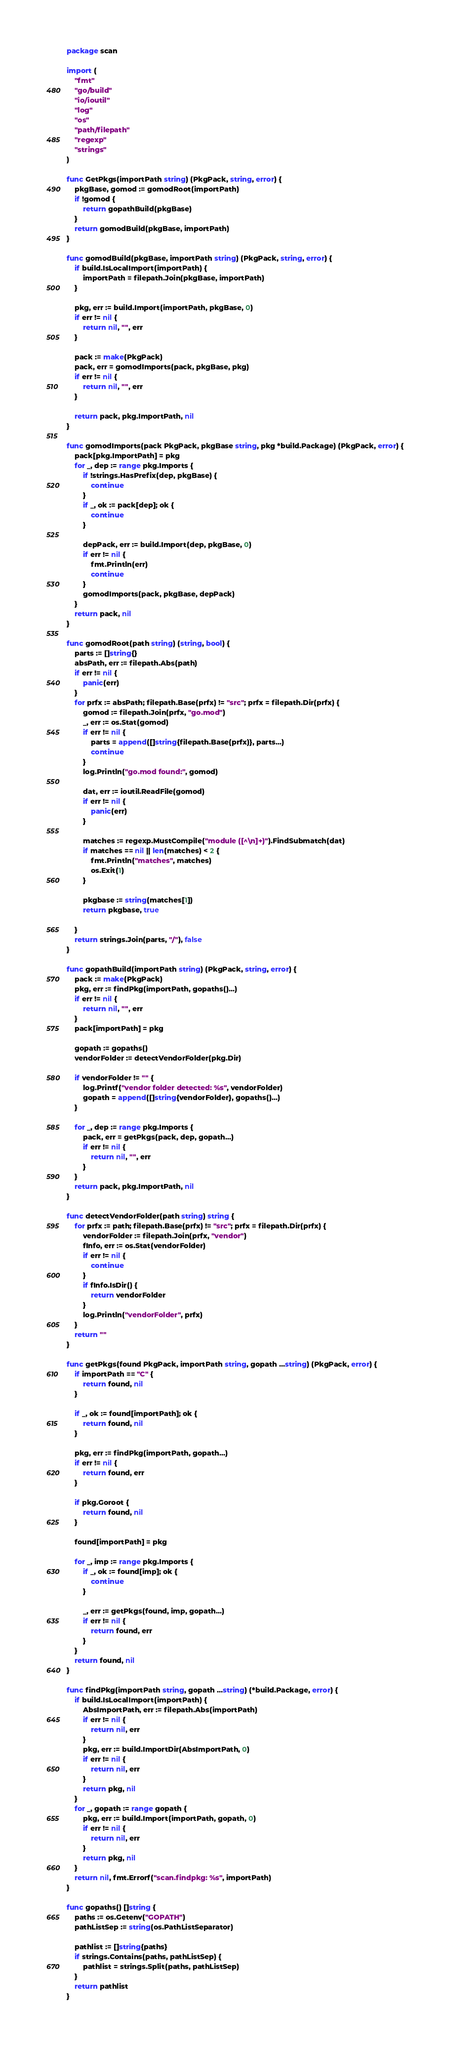Convert code to text. <code><loc_0><loc_0><loc_500><loc_500><_Go_>package scan

import (
	"fmt"
	"go/build"
	"io/ioutil"
	"log"
	"os"
	"path/filepath"
	"regexp"
	"strings"
)

func GetPkgs(importPath string) (PkgPack, string, error) {
	pkgBase, gomod := gomodRoot(importPath)
	if !gomod {
		return gopathBuild(pkgBase)
	}
	return gomodBuild(pkgBase, importPath)
}

func gomodBuild(pkgBase, importPath string) (PkgPack, string, error) {
	if build.IsLocalImport(importPath) {
		importPath = filepath.Join(pkgBase, importPath)
	}

	pkg, err := build.Import(importPath, pkgBase, 0)
	if err != nil {
		return nil, "", err
	}

	pack := make(PkgPack)
	pack, err = gomodImports(pack, pkgBase, pkg)
	if err != nil {
		return nil, "", err
	}

	return pack, pkg.ImportPath, nil
}

func gomodImports(pack PkgPack, pkgBase string, pkg *build.Package) (PkgPack, error) {
	pack[pkg.ImportPath] = pkg
	for _, dep := range pkg.Imports {
		if !strings.HasPrefix(dep, pkgBase) {
			continue
		}
		if _, ok := pack[dep]; ok {
			continue
		}

		depPack, err := build.Import(dep, pkgBase, 0)
		if err != nil {
			fmt.Println(err)
			continue
		}
		gomodImports(pack, pkgBase, depPack)
	}
	return pack, nil
}

func gomodRoot(path string) (string, bool) {
	parts := []string{}
	absPath, err := filepath.Abs(path)
	if err != nil {
		panic(err)
	}
	for prfx := absPath; filepath.Base(prfx) != "src"; prfx = filepath.Dir(prfx) {
		gomod := filepath.Join(prfx, "go.mod")
		_, err := os.Stat(gomod)
		if err != nil {
			parts = append([]string{filepath.Base(prfx)}, parts...)
			continue
		}
		log.Println("go.mod found:", gomod)

		dat, err := ioutil.ReadFile(gomod)
		if err != nil {
			panic(err)
		}

		matches := regexp.MustCompile("module ([^\n]+)").FindSubmatch(dat)
		if matches == nil || len(matches) < 2 {
			fmt.Println("matches", matches)
			os.Exit(1)
		}

		pkgbase := string(matches[1])
		return pkgbase, true

	}
	return strings.Join(parts, "/"), false
}

func gopathBuild(importPath string) (PkgPack, string, error) {
	pack := make(PkgPack)
	pkg, err := findPkg(importPath, gopaths()...)
	if err != nil {
		return nil, "", err
	}
	pack[importPath] = pkg

	gopath := gopaths()
	vendorFolder := detectVendorFolder(pkg.Dir)

	if vendorFolder != "" {
		log.Printf("vendor folder detected: %s", vendorFolder)
		gopath = append([]string{vendorFolder}, gopaths()...)
	}

	for _, dep := range pkg.Imports {
		pack, err = getPkgs(pack, dep, gopath...)
		if err != nil {
			return nil, "", err
		}
	}
	return pack, pkg.ImportPath, nil
}

func detectVendorFolder(path string) string {
	for prfx := path; filepath.Base(prfx) != "src"; prfx = filepath.Dir(prfx) {
		vendorFolder := filepath.Join(prfx, "vendor")
		fInfo, err := os.Stat(vendorFolder)
		if err != nil {
			continue
		}
		if fInfo.IsDir() {
			return vendorFolder
		}
		log.Println("vendorFolder", prfx)
	}
	return ""
}

func getPkgs(found PkgPack, importPath string, gopath ...string) (PkgPack, error) {
	if importPath == "C" {
		return found, nil
	}

	if _, ok := found[importPath]; ok {
		return found, nil
	}

	pkg, err := findPkg(importPath, gopath...)
	if err != nil {
		return found, err
	}

	if pkg.Goroot {
		return found, nil
	}

	found[importPath] = pkg

	for _, imp := range pkg.Imports {
		if _, ok := found[imp]; ok {
			continue
		}

		_, err := getPkgs(found, imp, gopath...)
		if err != nil {
			return found, err
		}
	}
	return found, nil
}

func findPkg(importPath string, gopath ...string) (*build.Package, error) {
	if build.IsLocalImport(importPath) {
		AbsImportPath, err := filepath.Abs(importPath)
		if err != nil {
			return nil, err
		}
		pkg, err := build.ImportDir(AbsImportPath, 0)
		if err != nil {
			return nil, err
		}
		return pkg, nil
	}
	for _, gopath := range gopath {
		pkg, err := build.Import(importPath, gopath, 0)
		if err != nil {
			return nil, err
		}
		return pkg, nil
	}
	return nil, fmt.Errorf("scan.findpkg: %s", importPath)
}

func gopaths() []string {
	paths := os.Getenv("GOPATH")
	pathListSep := string(os.PathListSeparator)

	pathlist := []string{paths}
	if strings.Contains(paths, pathListSep) {
		pathlist = strings.Split(paths, pathListSep)
	}
	return pathlist
}
</code> 